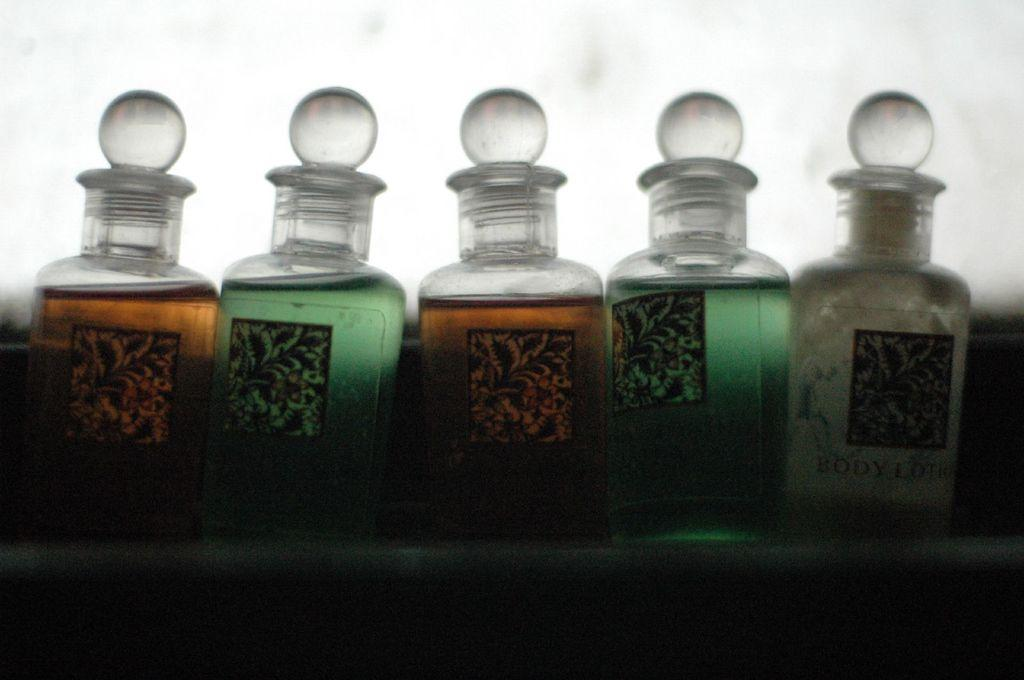What type of containers are present in the image? There are jar bottles in the image. What is inside the jar bottles? The jar bottles contain liquid. What type of memory is stored in the jar bottles? There is no memory stored in the jar bottles; they contain liquid. What type of iron can be seen in the image? There is no iron present in the image. 